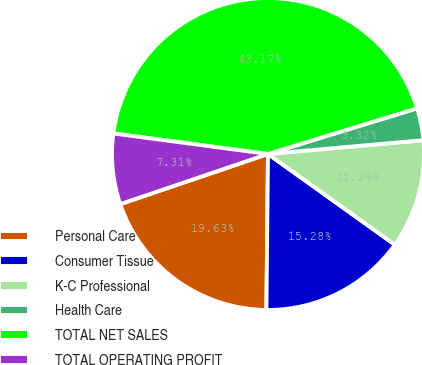Convert chart. <chart><loc_0><loc_0><loc_500><loc_500><pie_chart><fcel>Personal Care<fcel>Consumer Tissue<fcel>K-C Professional<fcel>Health Care<fcel>TOTAL NET SALES<fcel>TOTAL OPERATING PROFIT<nl><fcel>19.63%<fcel>15.28%<fcel>11.29%<fcel>3.32%<fcel>43.17%<fcel>7.31%<nl></chart> 